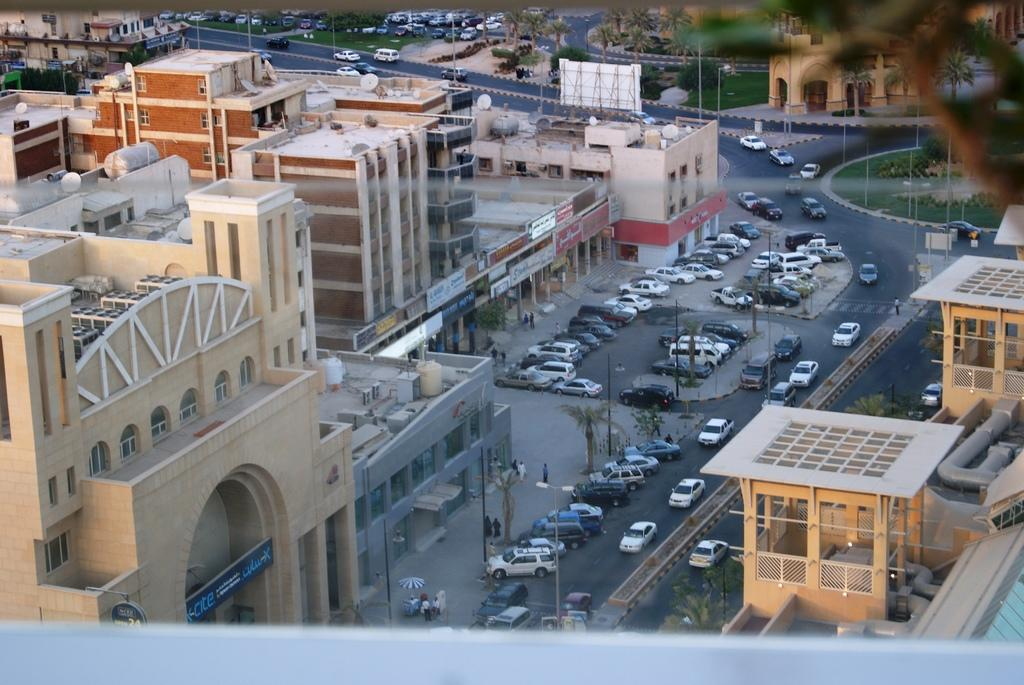What type of structures can be seen in the image? There are buildings in the image. What else is present in the image besides buildings? There are vehicles and trees in the image. Can you see a guide leading a group of tourists in the image? There is no guide or group of tourists present in the image. What type of plant can be seen growing in the image? There is no plant visible in the image; only buildings, vehicles, and trees are present. 